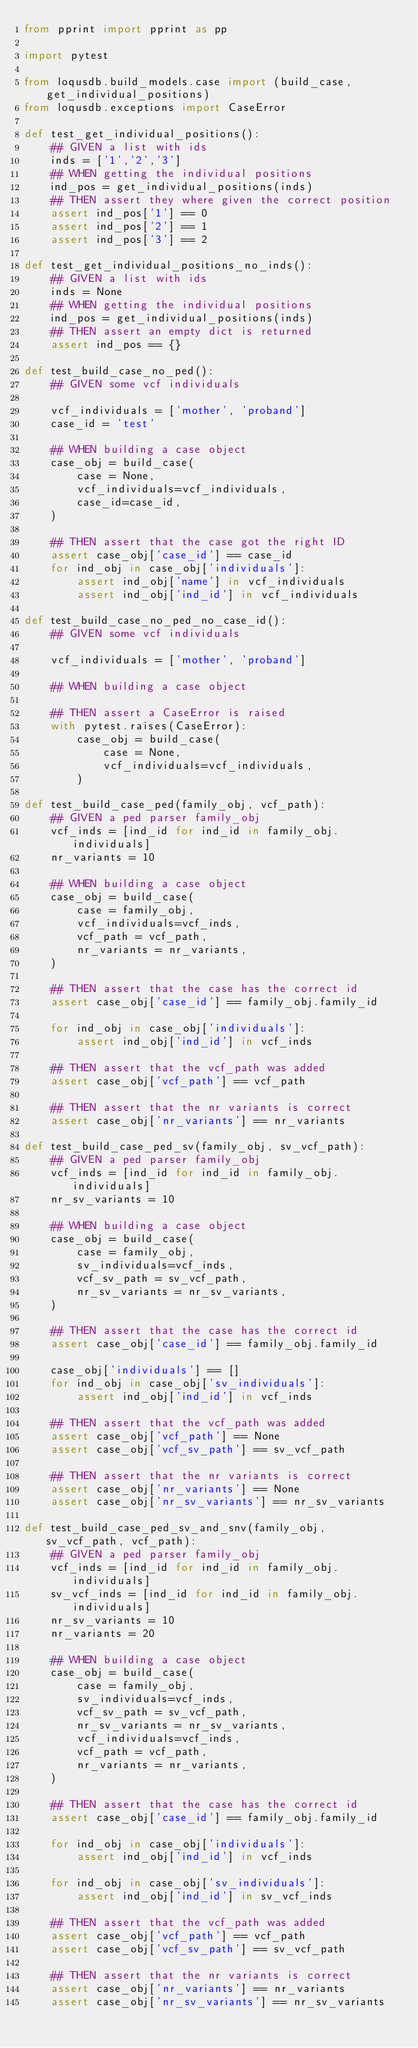<code> <loc_0><loc_0><loc_500><loc_500><_Python_>from pprint import pprint as pp

import pytest

from loqusdb.build_models.case import (build_case, get_individual_positions)
from loqusdb.exceptions import CaseError

def test_get_individual_positions():
    ## GIVEN a list with ids
    inds = ['1','2','3']
    ## WHEN getting the individual positions
    ind_pos = get_individual_positions(inds)
    ## THEN assert they where given the correct position
    assert ind_pos['1'] == 0
    assert ind_pos['2'] == 1
    assert ind_pos['3'] == 2

def test_get_individual_positions_no_inds():
    ## GIVEN a list with ids
    inds = None
    ## WHEN getting the individual positions
    ind_pos = get_individual_positions(inds)
    ## THEN assert an empty dict is returned
    assert ind_pos == {}
    
def test_build_case_no_ped():
    ## GIVEN some vcf individuals
    
    vcf_individuals = ['mother', 'proband']
    case_id = 'test'
    
    ## WHEN building a case object
    case_obj = build_case(
        case = None, 
        vcf_individuals=vcf_individuals, 
        case_id=case_id, 
    )
    
    ## THEN assert that the case got the right ID
    assert case_obj['case_id'] == case_id
    for ind_obj in case_obj['individuals']:
        assert ind_obj['name'] in vcf_individuals
        assert ind_obj['ind_id'] in vcf_individuals

def test_build_case_no_ped_no_case_id():
    ## GIVEN some vcf individuals
    
    vcf_individuals = ['mother', 'proband']
    
    ## WHEN building a case object

    ## THEN assert a CaseError is raised
    with pytest.raises(CaseError):
        case_obj = build_case(
            case = None, 
            vcf_individuals=vcf_individuals, 
        )

def test_build_case_ped(family_obj, vcf_path):
    ## GIVEN a ped parser family_obj
    vcf_inds = [ind_id for ind_id in family_obj.individuals]
    nr_variants = 10
    
    ## WHEN building a case object
    case_obj = build_case(
        case = family_obj, 
        vcf_individuals=vcf_inds,
        vcf_path = vcf_path,
        nr_variants = nr_variants,
    )
    
    ## THEN assert that the case has the correct id 
    assert case_obj['case_id'] == family_obj.family_id
    
    for ind_obj in case_obj['individuals']:
        assert ind_obj['ind_id'] in vcf_inds
    
    ## THEN assert that the vcf_path was added
    assert case_obj['vcf_path'] == vcf_path

    ## THEN assert that the nr variants is correct
    assert case_obj['nr_variants'] == nr_variants

def test_build_case_ped_sv(family_obj, sv_vcf_path):
    ## GIVEN a ped parser family_obj
    vcf_inds = [ind_id for ind_id in family_obj.individuals]
    nr_sv_variants = 10
    
    ## WHEN building a case object
    case_obj = build_case(
        case = family_obj, 
        sv_individuals=vcf_inds,
        vcf_sv_path = sv_vcf_path,
        nr_sv_variants = nr_sv_variants,
    )
    
    ## THEN assert that the case has the correct id 
    assert case_obj['case_id'] == family_obj.family_id
    
    case_obj['individuals'] == []
    for ind_obj in case_obj['sv_individuals']:
        assert ind_obj['ind_id'] in vcf_inds
    
    ## THEN assert that the vcf_path was added
    assert case_obj['vcf_path'] == None
    assert case_obj['vcf_sv_path'] == sv_vcf_path

    ## THEN assert that the nr variants is correct
    assert case_obj['nr_variants'] == None
    assert case_obj['nr_sv_variants'] == nr_sv_variants

def test_build_case_ped_sv_and_snv(family_obj, sv_vcf_path, vcf_path):
    ## GIVEN a ped parser family_obj
    vcf_inds = [ind_id for ind_id in family_obj.individuals]
    sv_vcf_inds = [ind_id for ind_id in family_obj.individuals]
    nr_sv_variants = 10
    nr_variants = 20
    
    ## WHEN building a case object
    case_obj = build_case(
        case = family_obj, 
        sv_individuals=vcf_inds,
        vcf_sv_path = sv_vcf_path,
        nr_sv_variants = nr_sv_variants,
        vcf_individuals=vcf_inds,
        vcf_path = vcf_path,
        nr_variants = nr_variants,
    )
    
    ## THEN assert that the case has the correct id 
    assert case_obj['case_id'] == family_obj.family_id
    
    for ind_obj in case_obj['individuals']:
        assert ind_obj['ind_id'] in vcf_inds

    for ind_obj in case_obj['sv_individuals']:
        assert ind_obj['ind_id'] in sv_vcf_inds
    
    ## THEN assert that the vcf_path was added
    assert case_obj['vcf_path'] == vcf_path
    assert case_obj['vcf_sv_path'] == sv_vcf_path

    ## THEN assert that the nr variants is correct
    assert case_obj['nr_variants'] == nr_variants
    assert case_obj['nr_sv_variants'] == nr_sv_variants
</code> 